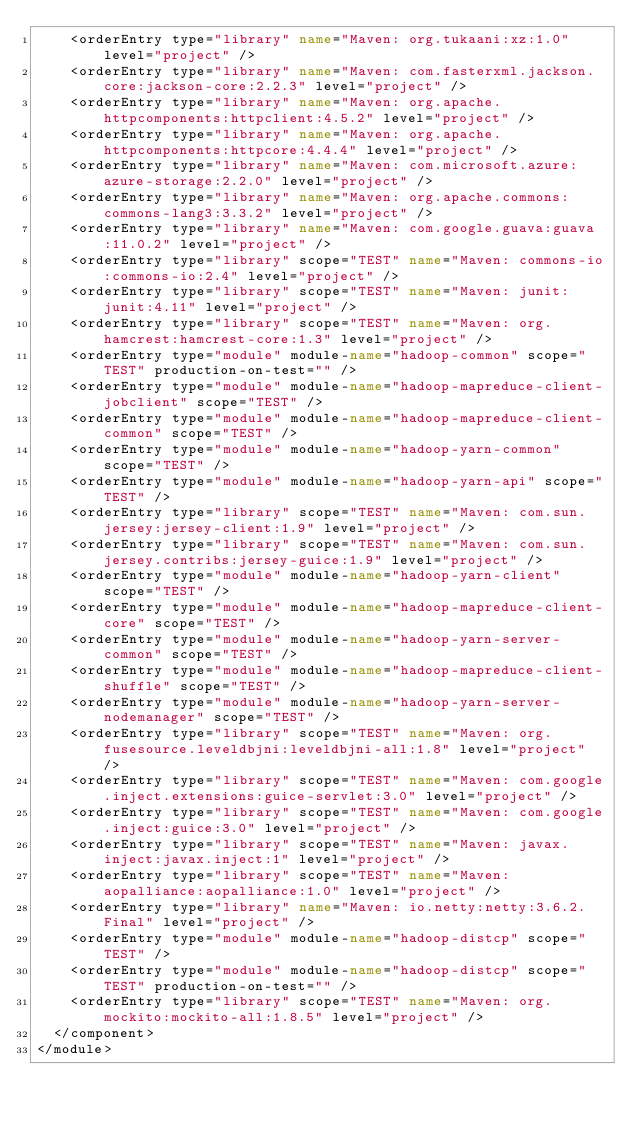<code> <loc_0><loc_0><loc_500><loc_500><_XML_>    <orderEntry type="library" name="Maven: org.tukaani:xz:1.0" level="project" />
    <orderEntry type="library" name="Maven: com.fasterxml.jackson.core:jackson-core:2.2.3" level="project" />
    <orderEntry type="library" name="Maven: org.apache.httpcomponents:httpclient:4.5.2" level="project" />
    <orderEntry type="library" name="Maven: org.apache.httpcomponents:httpcore:4.4.4" level="project" />
    <orderEntry type="library" name="Maven: com.microsoft.azure:azure-storage:2.2.0" level="project" />
    <orderEntry type="library" name="Maven: org.apache.commons:commons-lang3:3.3.2" level="project" />
    <orderEntry type="library" name="Maven: com.google.guava:guava:11.0.2" level="project" />
    <orderEntry type="library" scope="TEST" name="Maven: commons-io:commons-io:2.4" level="project" />
    <orderEntry type="library" scope="TEST" name="Maven: junit:junit:4.11" level="project" />
    <orderEntry type="library" scope="TEST" name="Maven: org.hamcrest:hamcrest-core:1.3" level="project" />
    <orderEntry type="module" module-name="hadoop-common" scope="TEST" production-on-test="" />
    <orderEntry type="module" module-name="hadoop-mapreduce-client-jobclient" scope="TEST" />
    <orderEntry type="module" module-name="hadoop-mapreduce-client-common" scope="TEST" />
    <orderEntry type="module" module-name="hadoop-yarn-common" scope="TEST" />
    <orderEntry type="module" module-name="hadoop-yarn-api" scope="TEST" />
    <orderEntry type="library" scope="TEST" name="Maven: com.sun.jersey:jersey-client:1.9" level="project" />
    <orderEntry type="library" scope="TEST" name="Maven: com.sun.jersey.contribs:jersey-guice:1.9" level="project" />
    <orderEntry type="module" module-name="hadoop-yarn-client" scope="TEST" />
    <orderEntry type="module" module-name="hadoop-mapreduce-client-core" scope="TEST" />
    <orderEntry type="module" module-name="hadoop-yarn-server-common" scope="TEST" />
    <orderEntry type="module" module-name="hadoop-mapreduce-client-shuffle" scope="TEST" />
    <orderEntry type="module" module-name="hadoop-yarn-server-nodemanager" scope="TEST" />
    <orderEntry type="library" scope="TEST" name="Maven: org.fusesource.leveldbjni:leveldbjni-all:1.8" level="project" />
    <orderEntry type="library" scope="TEST" name="Maven: com.google.inject.extensions:guice-servlet:3.0" level="project" />
    <orderEntry type="library" scope="TEST" name="Maven: com.google.inject:guice:3.0" level="project" />
    <orderEntry type="library" scope="TEST" name="Maven: javax.inject:javax.inject:1" level="project" />
    <orderEntry type="library" scope="TEST" name="Maven: aopalliance:aopalliance:1.0" level="project" />
    <orderEntry type="library" name="Maven: io.netty:netty:3.6.2.Final" level="project" />
    <orderEntry type="module" module-name="hadoop-distcp" scope="TEST" />
    <orderEntry type="module" module-name="hadoop-distcp" scope="TEST" production-on-test="" />
    <orderEntry type="library" scope="TEST" name="Maven: org.mockito:mockito-all:1.8.5" level="project" />
  </component>
</module></code> 